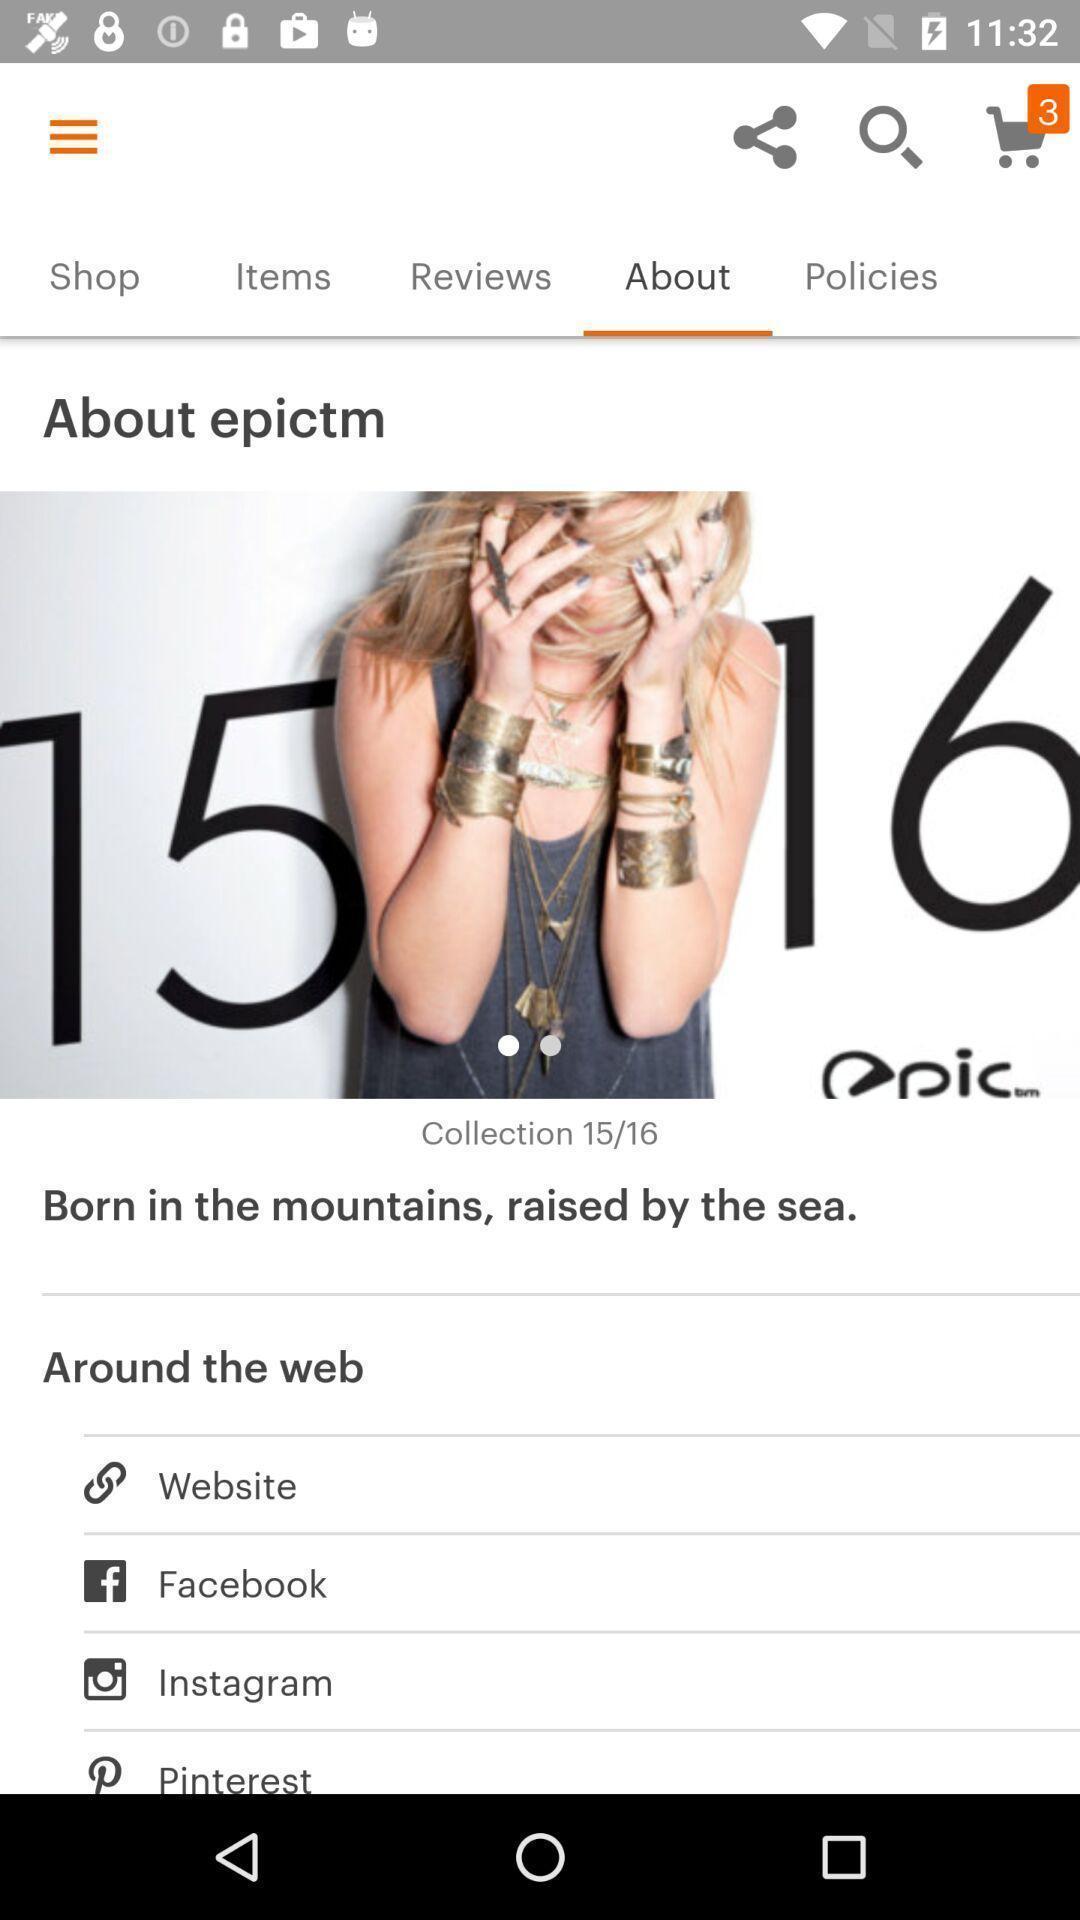Summarize the main components in this picture. Screen shows about details in a shopping app. 